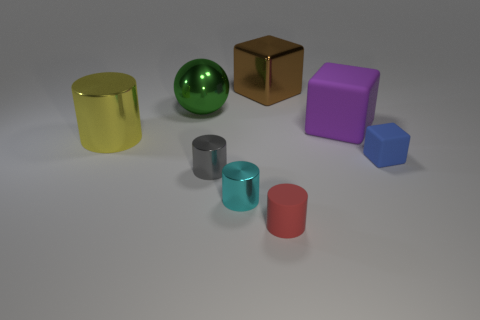Are there an equal number of yellow metal things to the left of the big purple thing and small cyan balls?
Provide a short and direct response. No. How many objects are either metal blocks or shiny cylinders in front of the blue thing?
Your answer should be compact. 3. Is there a green metal thing of the same shape as the tiny gray object?
Provide a succinct answer. No. Are there the same number of cyan metallic objects that are left of the purple block and small blue things that are behind the brown metal block?
Provide a succinct answer. No. Is there any other thing that has the same size as the green metal sphere?
Your answer should be compact. Yes. What number of gray objects are either small metal objects or spheres?
Provide a short and direct response. 1. How many red matte cylinders have the same size as the green metallic object?
Offer a terse response. 0. The big object that is in front of the large brown cube and to the right of the green sphere is what color?
Your answer should be compact. Purple. Is the number of tiny rubber blocks that are behind the large brown shiny block greater than the number of green metallic objects?
Provide a succinct answer. No. Are any large purple metallic blocks visible?
Your response must be concise. No. 